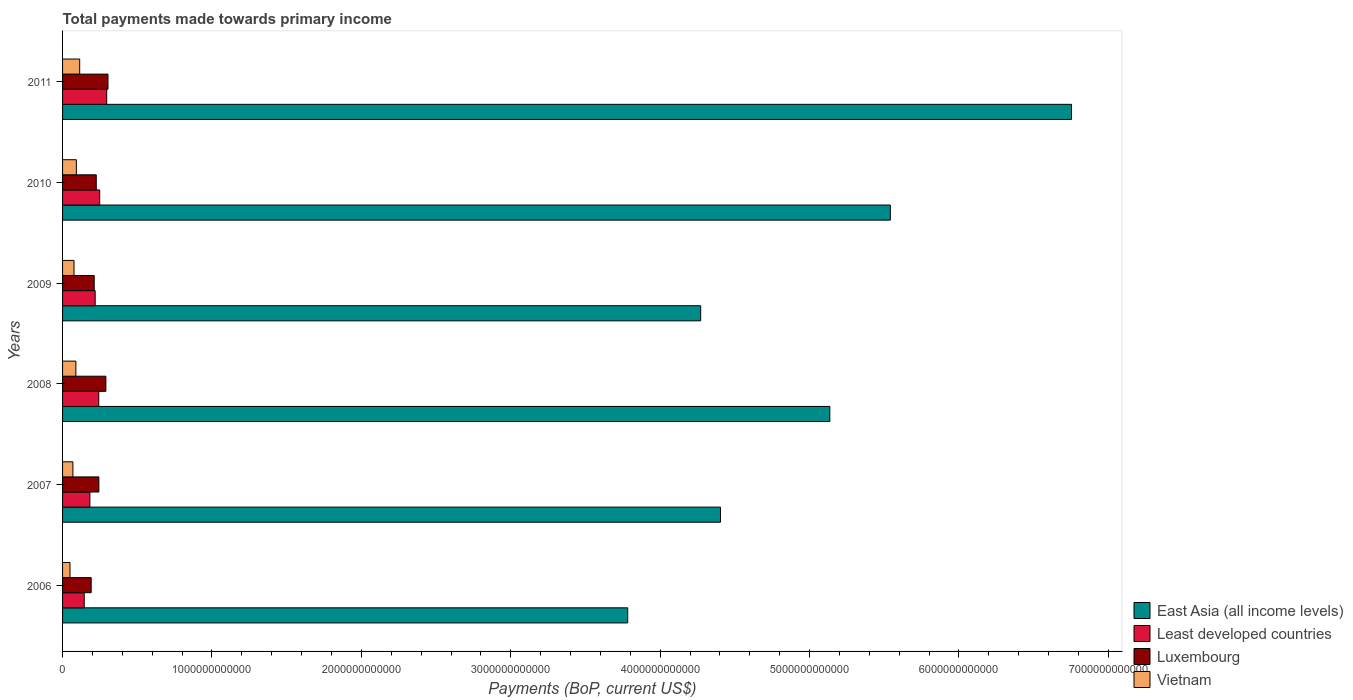How many different coloured bars are there?
Keep it short and to the point. 4. How many groups of bars are there?
Give a very brief answer. 6. Are the number of bars per tick equal to the number of legend labels?
Your response must be concise. Yes. Are the number of bars on each tick of the Y-axis equal?
Your answer should be compact. Yes. How many bars are there on the 6th tick from the top?
Your answer should be compact. 4. How many bars are there on the 4th tick from the bottom?
Offer a very short reply. 4. What is the total payments made towards primary income in Vietnam in 2010?
Give a very brief answer. 9.23e+1. Across all years, what is the maximum total payments made towards primary income in East Asia (all income levels)?
Provide a succinct answer. 6.75e+12. Across all years, what is the minimum total payments made towards primary income in Luxembourg?
Keep it short and to the point. 1.91e+11. In which year was the total payments made towards primary income in East Asia (all income levels) minimum?
Your answer should be compact. 2006. What is the total total payments made towards primary income in Least developed countries in the graph?
Your answer should be compact. 1.33e+12. What is the difference between the total payments made towards primary income in Vietnam in 2009 and that in 2011?
Offer a very short reply. -3.80e+1. What is the difference between the total payments made towards primary income in Least developed countries in 2009 and the total payments made towards primary income in Vietnam in 2011?
Provide a succinct answer. 1.04e+11. What is the average total payments made towards primary income in East Asia (all income levels) per year?
Keep it short and to the point. 4.98e+12. In the year 2011, what is the difference between the total payments made towards primary income in Vietnam and total payments made towards primary income in East Asia (all income levels)?
Your response must be concise. -6.64e+12. In how many years, is the total payments made towards primary income in East Asia (all income levels) greater than 3400000000000 US$?
Provide a succinct answer. 6. What is the ratio of the total payments made towards primary income in Vietnam in 2009 to that in 2010?
Keep it short and to the point. 0.83. Is the total payments made towards primary income in Luxembourg in 2006 less than that in 2007?
Provide a short and direct response. Yes. Is the difference between the total payments made towards primary income in Vietnam in 2009 and 2011 greater than the difference between the total payments made towards primary income in East Asia (all income levels) in 2009 and 2011?
Your answer should be compact. Yes. What is the difference between the highest and the second highest total payments made towards primary income in Luxembourg?
Provide a succinct answer. 1.41e+1. What is the difference between the highest and the lowest total payments made towards primary income in East Asia (all income levels)?
Give a very brief answer. 2.97e+12. In how many years, is the total payments made towards primary income in Luxembourg greater than the average total payments made towards primary income in Luxembourg taken over all years?
Keep it short and to the point. 2. What does the 1st bar from the top in 2009 represents?
Offer a very short reply. Vietnam. What does the 4th bar from the bottom in 2007 represents?
Your answer should be compact. Vietnam. Are all the bars in the graph horizontal?
Your answer should be very brief. Yes. What is the difference between two consecutive major ticks on the X-axis?
Your answer should be very brief. 1.00e+12. Does the graph contain any zero values?
Keep it short and to the point. No. How many legend labels are there?
Offer a very short reply. 4. How are the legend labels stacked?
Your answer should be compact. Vertical. What is the title of the graph?
Provide a succinct answer. Total payments made towards primary income. What is the label or title of the X-axis?
Give a very brief answer. Payments (BoP, current US$). What is the label or title of the Y-axis?
Provide a short and direct response. Years. What is the Payments (BoP, current US$) of East Asia (all income levels) in 2006?
Your response must be concise. 3.78e+12. What is the Payments (BoP, current US$) of Least developed countries in 2006?
Make the answer very short. 1.45e+11. What is the Payments (BoP, current US$) of Luxembourg in 2006?
Offer a very short reply. 1.91e+11. What is the Payments (BoP, current US$) of Vietnam in 2006?
Keep it short and to the point. 4.98e+1. What is the Payments (BoP, current US$) of East Asia (all income levels) in 2007?
Offer a terse response. 4.40e+12. What is the Payments (BoP, current US$) of Least developed countries in 2007?
Keep it short and to the point. 1.83e+11. What is the Payments (BoP, current US$) in Luxembourg in 2007?
Keep it short and to the point. 2.43e+11. What is the Payments (BoP, current US$) of Vietnam in 2007?
Ensure brevity in your answer.  6.91e+1. What is the Payments (BoP, current US$) of East Asia (all income levels) in 2008?
Offer a very short reply. 5.14e+12. What is the Payments (BoP, current US$) of Least developed countries in 2008?
Ensure brevity in your answer.  2.42e+11. What is the Payments (BoP, current US$) of Luxembourg in 2008?
Provide a succinct answer. 2.90e+11. What is the Payments (BoP, current US$) in Vietnam in 2008?
Your response must be concise. 8.92e+1. What is the Payments (BoP, current US$) of East Asia (all income levels) in 2009?
Ensure brevity in your answer.  4.27e+12. What is the Payments (BoP, current US$) of Least developed countries in 2009?
Provide a short and direct response. 2.18e+11. What is the Payments (BoP, current US$) of Luxembourg in 2009?
Ensure brevity in your answer.  2.12e+11. What is the Payments (BoP, current US$) of Vietnam in 2009?
Provide a succinct answer. 7.67e+1. What is the Payments (BoP, current US$) of East Asia (all income levels) in 2010?
Provide a short and direct response. 5.54e+12. What is the Payments (BoP, current US$) of Least developed countries in 2010?
Keep it short and to the point. 2.49e+11. What is the Payments (BoP, current US$) of Luxembourg in 2010?
Make the answer very short. 2.26e+11. What is the Payments (BoP, current US$) of Vietnam in 2010?
Your answer should be compact. 9.23e+1. What is the Payments (BoP, current US$) of East Asia (all income levels) in 2011?
Make the answer very short. 6.75e+12. What is the Payments (BoP, current US$) of Least developed countries in 2011?
Provide a succinct answer. 2.95e+11. What is the Payments (BoP, current US$) of Luxembourg in 2011?
Provide a succinct answer. 3.04e+11. What is the Payments (BoP, current US$) in Vietnam in 2011?
Make the answer very short. 1.15e+11. Across all years, what is the maximum Payments (BoP, current US$) of East Asia (all income levels)?
Give a very brief answer. 6.75e+12. Across all years, what is the maximum Payments (BoP, current US$) of Least developed countries?
Keep it short and to the point. 2.95e+11. Across all years, what is the maximum Payments (BoP, current US$) of Luxembourg?
Provide a succinct answer. 3.04e+11. Across all years, what is the maximum Payments (BoP, current US$) in Vietnam?
Provide a short and direct response. 1.15e+11. Across all years, what is the minimum Payments (BoP, current US$) in East Asia (all income levels)?
Offer a terse response. 3.78e+12. Across all years, what is the minimum Payments (BoP, current US$) of Least developed countries?
Give a very brief answer. 1.45e+11. Across all years, what is the minimum Payments (BoP, current US$) in Luxembourg?
Ensure brevity in your answer.  1.91e+11. Across all years, what is the minimum Payments (BoP, current US$) in Vietnam?
Ensure brevity in your answer.  4.98e+1. What is the total Payments (BoP, current US$) of East Asia (all income levels) in the graph?
Offer a very short reply. 2.99e+13. What is the total Payments (BoP, current US$) in Least developed countries in the graph?
Make the answer very short. 1.33e+12. What is the total Payments (BoP, current US$) in Luxembourg in the graph?
Your response must be concise. 1.47e+12. What is the total Payments (BoP, current US$) in Vietnam in the graph?
Your response must be concise. 4.92e+11. What is the difference between the Payments (BoP, current US$) of East Asia (all income levels) in 2006 and that in 2007?
Ensure brevity in your answer.  -6.21e+11. What is the difference between the Payments (BoP, current US$) of Least developed countries in 2006 and that in 2007?
Your answer should be very brief. -3.78e+1. What is the difference between the Payments (BoP, current US$) in Luxembourg in 2006 and that in 2007?
Provide a short and direct response. -5.16e+1. What is the difference between the Payments (BoP, current US$) in Vietnam in 2006 and that in 2007?
Give a very brief answer. -1.93e+1. What is the difference between the Payments (BoP, current US$) of East Asia (all income levels) in 2006 and that in 2008?
Keep it short and to the point. -1.35e+12. What is the difference between the Payments (BoP, current US$) in Least developed countries in 2006 and that in 2008?
Provide a short and direct response. -9.73e+1. What is the difference between the Payments (BoP, current US$) of Luxembourg in 2006 and that in 2008?
Your response must be concise. -9.85e+1. What is the difference between the Payments (BoP, current US$) in Vietnam in 2006 and that in 2008?
Provide a succinct answer. -3.94e+1. What is the difference between the Payments (BoP, current US$) in East Asia (all income levels) in 2006 and that in 2009?
Your answer should be compact. -4.89e+11. What is the difference between the Payments (BoP, current US$) of Least developed countries in 2006 and that in 2009?
Provide a short and direct response. -7.33e+1. What is the difference between the Payments (BoP, current US$) of Luxembourg in 2006 and that in 2009?
Provide a short and direct response. -2.05e+1. What is the difference between the Payments (BoP, current US$) in Vietnam in 2006 and that in 2009?
Give a very brief answer. -2.69e+1. What is the difference between the Payments (BoP, current US$) in East Asia (all income levels) in 2006 and that in 2010?
Keep it short and to the point. -1.76e+12. What is the difference between the Payments (BoP, current US$) in Least developed countries in 2006 and that in 2010?
Keep it short and to the point. -1.04e+11. What is the difference between the Payments (BoP, current US$) in Luxembourg in 2006 and that in 2010?
Ensure brevity in your answer.  -3.42e+1. What is the difference between the Payments (BoP, current US$) of Vietnam in 2006 and that in 2010?
Give a very brief answer. -4.25e+1. What is the difference between the Payments (BoP, current US$) of East Asia (all income levels) in 2006 and that in 2011?
Make the answer very short. -2.97e+12. What is the difference between the Payments (BoP, current US$) of Least developed countries in 2006 and that in 2011?
Your response must be concise. -1.50e+11. What is the difference between the Payments (BoP, current US$) in Luxembourg in 2006 and that in 2011?
Your response must be concise. -1.13e+11. What is the difference between the Payments (BoP, current US$) of Vietnam in 2006 and that in 2011?
Your answer should be very brief. -6.48e+1. What is the difference between the Payments (BoP, current US$) in East Asia (all income levels) in 2007 and that in 2008?
Offer a very short reply. -7.32e+11. What is the difference between the Payments (BoP, current US$) in Least developed countries in 2007 and that in 2008?
Your response must be concise. -5.95e+1. What is the difference between the Payments (BoP, current US$) in Luxembourg in 2007 and that in 2008?
Ensure brevity in your answer.  -4.70e+1. What is the difference between the Payments (BoP, current US$) in Vietnam in 2007 and that in 2008?
Make the answer very short. -2.00e+1. What is the difference between the Payments (BoP, current US$) of East Asia (all income levels) in 2007 and that in 2009?
Your response must be concise. 1.33e+11. What is the difference between the Payments (BoP, current US$) in Least developed countries in 2007 and that in 2009?
Your answer should be compact. -3.54e+1. What is the difference between the Payments (BoP, current US$) of Luxembourg in 2007 and that in 2009?
Your answer should be compact. 3.11e+1. What is the difference between the Payments (BoP, current US$) of Vietnam in 2007 and that in 2009?
Provide a succinct answer. -7.53e+09. What is the difference between the Payments (BoP, current US$) in East Asia (all income levels) in 2007 and that in 2010?
Your answer should be very brief. -1.14e+12. What is the difference between the Payments (BoP, current US$) of Least developed countries in 2007 and that in 2010?
Give a very brief answer. -6.57e+1. What is the difference between the Payments (BoP, current US$) in Luxembourg in 2007 and that in 2010?
Keep it short and to the point. 1.74e+1. What is the difference between the Payments (BoP, current US$) of Vietnam in 2007 and that in 2010?
Your answer should be very brief. -2.32e+1. What is the difference between the Payments (BoP, current US$) of East Asia (all income levels) in 2007 and that in 2011?
Offer a very short reply. -2.35e+12. What is the difference between the Payments (BoP, current US$) of Least developed countries in 2007 and that in 2011?
Your answer should be compact. -1.13e+11. What is the difference between the Payments (BoP, current US$) in Luxembourg in 2007 and that in 2011?
Provide a short and direct response. -6.10e+1. What is the difference between the Payments (BoP, current US$) of Vietnam in 2007 and that in 2011?
Provide a succinct answer. -4.55e+1. What is the difference between the Payments (BoP, current US$) of East Asia (all income levels) in 2008 and that in 2009?
Offer a terse response. 8.64e+11. What is the difference between the Payments (BoP, current US$) in Least developed countries in 2008 and that in 2009?
Keep it short and to the point. 2.40e+1. What is the difference between the Payments (BoP, current US$) of Luxembourg in 2008 and that in 2009?
Offer a very short reply. 7.80e+1. What is the difference between the Payments (BoP, current US$) in Vietnam in 2008 and that in 2009?
Provide a succinct answer. 1.25e+1. What is the difference between the Payments (BoP, current US$) in East Asia (all income levels) in 2008 and that in 2010?
Provide a short and direct response. -4.05e+11. What is the difference between the Payments (BoP, current US$) in Least developed countries in 2008 and that in 2010?
Ensure brevity in your answer.  -6.20e+09. What is the difference between the Payments (BoP, current US$) in Luxembourg in 2008 and that in 2010?
Keep it short and to the point. 6.43e+1. What is the difference between the Payments (BoP, current US$) of Vietnam in 2008 and that in 2010?
Provide a succinct answer. -3.13e+09. What is the difference between the Payments (BoP, current US$) of East Asia (all income levels) in 2008 and that in 2011?
Ensure brevity in your answer.  -1.62e+12. What is the difference between the Payments (BoP, current US$) of Least developed countries in 2008 and that in 2011?
Ensure brevity in your answer.  -5.31e+1. What is the difference between the Payments (BoP, current US$) of Luxembourg in 2008 and that in 2011?
Give a very brief answer. -1.41e+1. What is the difference between the Payments (BoP, current US$) in Vietnam in 2008 and that in 2011?
Offer a very short reply. -2.54e+1. What is the difference between the Payments (BoP, current US$) of East Asia (all income levels) in 2009 and that in 2010?
Give a very brief answer. -1.27e+12. What is the difference between the Payments (BoP, current US$) in Least developed countries in 2009 and that in 2010?
Make the answer very short. -3.02e+1. What is the difference between the Payments (BoP, current US$) in Luxembourg in 2009 and that in 2010?
Make the answer very short. -1.37e+1. What is the difference between the Payments (BoP, current US$) of Vietnam in 2009 and that in 2010?
Your answer should be compact. -1.56e+1. What is the difference between the Payments (BoP, current US$) of East Asia (all income levels) in 2009 and that in 2011?
Your answer should be compact. -2.48e+12. What is the difference between the Payments (BoP, current US$) in Least developed countries in 2009 and that in 2011?
Offer a terse response. -7.71e+1. What is the difference between the Payments (BoP, current US$) of Luxembourg in 2009 and that in 2011?
Provide a short and direct response. -9.21e+1. What is the difference between the Payments (BoP, current US$) in Vietnam in 2009 and that in 2011?
Offer a very short reply. -3.80e+1. What is the difference between the Payments (BoP, current US$) of East Asia (all income levels) in 2010 and that in 2011?
Provide a succinct answer. -1.21e+12. What is the difference between the Payments (BoP, current US$) of Least developed countries in 2010 and that in 2011?
Offer a very short reply. -4.69e+1. What is the difference between the Payments (BoP, current US$) in Luxembourg in 2010 and that in 2011?
Provide a succinct answer. -7.84e+1. What is the difference between the Payments (BoP, current US$) of Vietnam in 2010 and that in 2011?
Your response must be concise. -2.23e+1. What is the difference between the Payments (BoP, current US$) of East Asia (all income levels) in 2006 and the Payments (BoP, current US$) of Least developed countries in 2007?
Make the answer very short. 3.60e+12. What is the difference between the Payments (BoP, current US$) of East Asia (all income levels) in 2006 and the Payments (BoP, current US$) of Luxembourg in 2007?
Ensure brevity in your answer.  3.54e+12. What is the difference between the Payments (BoP, current US$) of East Asia (all income levels) in 2006 and the Payments (BoP, current US$) of Vietnam in 2007?
Make the answer very short. 3.71e+12. What is the difference between the Payments (BoP, current US$) of Least developed countries in 2006 and the Payments (BoP, current US$) of Luxembourg in 2007?
Ensure brevity in your answer.  -9.80e+1. What is the difference between the Payments (BoP, current US$) of Least developed countries in 2006 and the Payments (BoP, current US$) of Vietnam in 2007?
Your response must be concise. 7.59e+1. What is the difference between the Payments (BoP, current US$) in Luxembourg in 2006 and the Payments (BoP, current US$) in Vietnam in 2007?
Give a very brief answer. 1.22e+11. What is the difference between the Payments (BoP, current US$) in East Asia (all income levels) in 2006 and the Payments (BoP, current US$) in Least developed countries in 2008?
Ensure brevity in your answer.  3.54e+12. What is the difference between the Payments (BoP, current US$) of East Asia (all income levels) in 2006 and the Payments (BoP, current US$) of Luxembourg in 2008?
Keep it short and to the point. 3.49e+12. What is the difference between the Payments (BoP, current US$) of East Asia (all income levels) in 2006 and the Payments (BoP, current US$) of Vietnam in 2008?
Your response must be concise. 3.69e+12. What is the difference between the Payments (BoP, current US$) in Least developed countries in 2006 and the Payments (BoP, current US$) in Luxembourg in 2008?
Provide a short and direct response. -1.45e+11. What is the difference between the Payments (BoP, current US$) in Least developed countries in 2006 and the Payments (BoP, current US$) in Vietnam in 2008?
Your response must be concise. 5.59e+1. What is the difference between the Payments (BoP, current US$) in Luxembourg in 2006 and the Payments (BoP, current US$) in Vietnam in 2008?
Keep it short and to the point. 1.02e+11. What is the difference between the Payments (BoP, current US$) of East Asia (all income levels) in 2006 and the Payments (BoP, current US$) of Least developed countries in 2009?
Provide a succinct answer. 3.56e+12. What is the difference between the Payments (BoP, current US$) in East Asia (all income levels) in 2006 and the Payments (BoP, current US$) in Luxembourg in 2009?
Your response must be concise. 3.57e+12. What is the difference between the Payments (BoP, current US$) in East Asia (all income levels) in 2006 and the Payments (BoP, current US$) in Vietnam in 2009?
Offer a terse response. 3.71e+12. What is the difference between the Payments (BoP, current US$) in Least developed countries in 2006 and the Payments (BoP, current US$) in Luxembourg in 2009?
Your response must be concise. -6.69e+1. What is the difference between the Payments (BoP, current US$) in Least developed countries in 2006 and the Payments (BoP, current US$) in Vietnam in 2009?
Your answer should be very brief. 6.84e+1. What is the difference between the Payments (BoP, current US$) in Luxembourg in 2006 and the Payments (BoP, current US$) in Vietnam in 2009?
Offer a terse response. 1.15e+11. What is the difference between the Payments (BoP, current US$) of East Asia (all income levels) in 2006 and the Payments (BoP, current US$) of Least developed countries in 2010?
Provide a short and direct response. 3.53e+12. What is the difference between the Payments (BoP, current US$) of East Asia (all income levels) in 2006 and the Payments (BoP, current US$) of Luxembourg in 2010?
Your answer should be very brief. 3.56e+12. What is the difference between the Payments (BoP, current US$) of East Asia (all income levels) in 2006 and the Payments (BoP, current US$) of Vietnam in 2010?
Your response must be concise. 3.69e+12. What is the difference between the Payments (BoP, current US$) in Least developed countries in 2006 and the Payments (BoP, current US$) in Luxembourg in 2010?
Your answer should be compact. -8.06e+1. What is the difference between the Payments (BoP, current US$) of Least developed countries in 2006 and the Payments (BoP, current US$) of Vietnam in 2010?
Make the answer very short. 5.27e+1. What is the difference between the Payments (BoP, current US$) in Luxembourg in 2006 and the Payments (BoP, current US$) in Vietnam in 2010?
Your answer should be compact. 9.91e+1. What is the difference between the Payments (BoP, current US$) in East Asia (all income levels) in 2006 and the Payments (BoP, current US$) in Least developed countries in 2011?
Your response must be concise. 3.49e+12. What is the difference between the Payments (BoP, current US$) of East Asia (all income levels) in 2006 and the Payments (BoP, current US$) of Luxembourg in 2011?
Make the answer very short. 3.48e+12. What is the difference between the Payments (BoP, current US$) of East Asia (all income levels) in 2006 and the Payments (BoP, current US$) of Vietnam in 2011?
Ensure brevity in your answer.  3.67e+12. What is the difference between the Payments (BoP, current US$) in Least developed countries in 2006 and the Payments (BoP, current US$) in Luxembourg in 2011?
Your answer should be very brief. -1.59e+11. What is the difference between the Payments (BoP, current US$) of Least developed countries in 2006 and the Payments (BoP, current US$) of Vietnam in 2011?
Your answer should be very brief. 3.04e+1. What is the difference between the Payments (BoP, current US$) of Luxembourg in 2006 and the Payments (BoP, current US$) of Vietnam in 2011?
Provide a succinct answer. 7.68e+1. What is the difference between the Payments (BoP, current US$) of East Asia (all income levels) in 2007 and the Payments (BoP, current US$) of Least developed countries in 2008?
Provide a succinct answer. 4.16e+12. What is the difference between the Payments (BoP, current US$) in East Asia (all income levels) in 2007 and the Payments (BoP, current US$) in Luxembourg in 2008?
Make the answer very short. 4.11e+12. What is the difference between the Payments (BoP, current US$) in East Asia (all income levels) in 2007 and the Payments (BoP, current US$) in Vietnam in 2008?
Make the answer very short. 4.31e+12. What is the difference between the Payments (BoP, current US$) in Least developed countries in 2007 and the Payments (BoP, current US$) in Luxembourg in 2008?
Your response must be concise. -1.07e+11. What is the difference between the Payments (BoP, current US$) in Least developed countries in 2007 and the Payments (BoP, current US$) in Vietnam in 2008?
Give a very brief answer. 9.37e+1. What is the difference between the Payments (BoP, current US$) in Luxembourg in 2007 and the Payments (BoP, current US$) in Vietnam in 2008?
Provide a succinct answer. 1.54e+11. What is the difference between the Payments (BoP, current US$) in East Asia (all income levels) in 2007 and the Payments (BoP, current US$) in Least developed countries in 2009?
Give a very brief answer. 4.19e+12. What is the difference between the Payments (BoP, current US$) of East Asia (all income levels) in 2007 and the Payments (BoP, current US$) of Luxembourg in 2009?
Give a very brief answer. 4.19e+12. What is the difference between the Payments (BoP, current US$) in East Asia (all income levels) in 2007 and the Payments (BoP, current US$) in Vietnam in 2009?
Your response must be concise. 4.33e+12. What is the difference between the Payments (BoP, current US$) in Least developed countries in 2007 and the Payments (BoP, current US$) in Luxembourg in 2009?
Ensure brevity in your answer.  -2.90e+1. What is the difference between the Payments (BoP, current US$) in Least developed countries in 2007 and the Payments (BoP, current US$) in Vietnam in 2009?
Offer a very short reply. 1.06e+11. What is the difference between the Payments (BoP, current US$) in Luxembourg in 2007 and the Payments (BoP, current US$) in Vietnam in 2009?
Your response must be concise. 1.66e+11. What is the difference between the Payments (BoP, current US$) in East Asia (all income levels) in 2007 and the Payments (BoP, current US$) in Least developed countries in 2010?
Offer a terse response. 4.16e+12. What is the difference between the Payments (BoP, current US$) of East Asia (all income levels) in 2007 and the Payments (BoP, current US$) of Luxembourg in 2010?
Your answer should be very brief. 4.18e+12. What is the difference between the Payments (BoP, current US$) in East Asia (all income levels) in 2007 and the Payments (BoP, current US$) in Vietnam in 2010?
Provide a succinct answer. 4.31e+12. What is the difference between the Payments (BoP, current US$) of Least developed countries in 2007 and the Payments (BoP, current US$) of Luxembourg in 2010?
Make the answer very short. -4.27e+1. What is the difference between the Payments (BoP, current US$) of Least developed countries in 2007 and the Payments (BoP, current US$) of Vietnam in 2010?
Make the answer very short. 9.06e+1. What is the difference between the Payments (BoP, current US$) of Luxembourg in 2007 and the Payments (BoP, current US$) of Vietnam in 2010?
Your answer should be very brief. 1.51e+11. What is the difference between the Payments (BoP, current US$) of East Asia (all income levels) in 2007 and the Payments (BoP, current US$) of Least developed countries in 2011?
Provide a succinct answer. 4.11e+12. What is the difference between the Payments (BoP, current US$) in East Asia (all income levels) in 2007 and the Payments (BoP, current US$) in Luxembourg in 2011?
Offer a terse response. 4.10e+12. What is the difference between the Payments (BoP, current US$) in East Asia (all income levels) in 2007 and the Payments (BoP, current US$) in Vietnam in 2011?
Give a very brief answer. 4.29e+12. What is the difference between the Payments (BoP, current US$) of Least developed countries in 2007 and the Payments (BoP, current US$) of Luxembourg in 2011?
Offer a terse response. -1.21e+11. What is the difference between the Payments (BoP, current US$) in Least developed countries in 2007 and the Payments (BoP, current US$) in Vietnam in 2011?
Your response must be concise. 6.82e+1. What is the difference between the Payments (BoP, current US$) in Luxembourg in 2007 and the Payments (BoP, current US$) in Vietnam in 2011?
Make the answer very short. 1.28e+11. What is the difference between the Payments (BoP, current US$) of East Asia (all income levels) in 2008 and the Payments (BoP, current US$) of Least developed countries in 2009?
Your answer should be very brief. 4.92e+12. What is the difference between the Payments (BoP, current US$) in East Asia (all income levels) in 2008 and the Payments (BoP, current US$) in Luxembourg in 2009?
Ensure brevity in your answer.  4.92e+12. What is the difference between the Payments (BoP, current US$) of East Asia (all income levels) in 2008 and the Payments (BoP, current US$) of Vietnam in 2009?
Keep it short and to the point. 5.06e+12. What is the difference between the Payments (BoP, current US$) of Least developed countries in 2008 and the Payments (BoP, current US$) of Luxembourg in 2009?
Give a very brief answer. 3.04e+1. What is the difference between the Payments (BoP, current US$) of Least developed countries in 2008 and the Payments (BoP, current US$) of Vietnam in 2009?
Make the answer very short. 1.66e+11. What is the difference between the Payments (BoP, current US$) in Luxembourg in 2008 and the Payments (BoP, current US$) in Vietnam in 2009?
Offer a terse response. 2.13e+11. What is the difference between the Payments (BoP, current US$) of East Asia (all income levels) in 2008 and the Payments (BoP, current US$) of Least developed countries in 2010?
Make the answer very short. 4.89e+12. What is the difference between the Payments (BoP, current US$) in East Asia (all income levels) in 2008 and the Payments (BoP, current US$) in Luxembourg in 2010?
Give a very brief answer. 4.91e+12. What is the difference between the Payments (BoP, current US$) in East Asia (all income levels) in 2008 and the Payments (BoP, current US$) in Vietnam in 2010?
Your response must be concise. 5.04e+12. What is the difference between the Payments (BoP, current US$) in Least developed countries in 2008 and the Payments (BoP, current US$) in Luxembourg in 2010?
Your answer should be compact. 1.67e+1. What is the difference between the Payments (BoP, current US$) of Least developed countries in 2008 and the Payments (BoP, current US$) of Vietnam in 2010?
Keep it short and to the point. 1.50e+11. What is the difference between the Payments (BoP, current US$) of Luxembourg in 2008 and the Payments (BoP, current US$) of Vietnam in 2010?
Provide a succinct answer. 1.98e+11. What is the difference between the Payments (BoP, current US$) in East Asia (all income levels) in 2008 and the Payments (BoP, current US$) in Least developed countries in 2011?
Keep it short and to the point. 4.84e+12. What is the difference between the Payments (BoP, current US$) in East Asia (all income levels) in 2008 and the Payments (BoP, current US$) in Luxembourg in 2011?
Your answer should be very brief. 4.83e+12. What is the difference between the Payments (BoP, current US$) in East Asia (all income levels) in 2008 and the Payments (BoP, current US$) in Vietnam in 2011?
Provide a succinct answer. 5.02e+12. What is the difference between the Payments (BoP, current US$) of Least developed countries in 2008 and the Payments (BoP, current US$) of Luxembourg in 2011?
Provide a short and direct response. -6.17e+1. What is the difference between the Payments (BoP, current US$) in Least developed countries in 2008 and the Payments (BoP, current US$) in Vietnam in 2011?
Provide a short and direct response. 1.28e+11. What is the difference between the Payments (BoP, current US$) of Luxembourg in 2008 and the Payments (BoP, current US$) of Vietnam in 2011?
Ensure brevity in your answer.  1.75e+11. What is the difference between the Payments (BoP, current US$) in East Asia (all income levels) in 2009 and the Payments (BoP, current US$) in Least developed countries in 2010?
Keep it short and to the point. 4.02e+12. What is the difference between the Payments (BoP, current US$) of East Asia (all income levels) in 2009 and the Payments (BoP, current US$) of Luxembourg in 2010?
Your answer should be compact. 4.05e+12. What is the difference between the Payments (BoP, current US$) in East Asia (all income levels) in 2009 and the Payments (BoP, current US$) in Vietnam in 2010?
Keep it short and to the point. 4.18e+12. What is the difference between the Payments (BoP, current US$) of Least developed countries in 2009 and the Payments (BoP, current US$) of Luxembourg in 2010?
Your answer should be compact. -7.30e+09. What is the difference between the Payments (BoP, current US$) of Least developed countries in 2009 and the Payments (BoP, current US$) of Vietnam in 2010?
Your answer should be very brief. 1.26e+11. What is the difference between the Payments (BoP, current US$) in Luxembourg in 2009 and the Payments (BoP, current US$) in Vietnam in 2010?
Give a very brief answer. 1.20e+11. What is the difference between the Payments (BoP, current US$) in East Asia (all income levels) in 2009 and the Payments (BoP, current US$) in Least developed countries in 2011?
Give a very brief answer. 3.98e+12. What is the difference between the Payments (BoP, current US$) of East Asia (all income levels) in 2009 and the Payments (BoP, current US$) of Luxembourg in 2011?
Offer a terse response. 3.97e+12. What is the difference between the Payments (BoP, current US$) of East Asia (all income levels) in 2009 and the Payments (BoP, current US$) of Vietnam in 2011?
Your response must be concise. 4.16e+12. What is the difference between the Payments (BoP, current US$) in Least developed countries in 2009 and the Payments (BoP, current US$) in Luxembourg in 2011?
Ensure brevity in your answer.  -8.57e+1. What is the difference between the Payments (BoP, current US$) in Least developed countries in 2009 and the Payments (BoP, current US$) in Vietnam in 2011?
Your answer should be very brief. 1.04e+11. What is the difference between the Payments (BoP, current US$) of Luxembourg in 2009 and the Payments (BoP, current US$) of Vietnam in 2011?
Your answer should be very brief. 9.73e+1. What is the difference between the Payments (BoP, current US$) in East Asia (all income levels) in 2010 and the Payments (BoP, current US$) in Least developed countries in 2011?
Ensure brevity in your answer.  5.25e+12. What is the difference between the Payments (BoP, current US$) in East Asia (all income levels) in 2010 and the Payments (BoP, current US$) in Luxembourg in 2011?
Provide a succinct answer. 5.24e+12. What is the difference between the Payments (BoP, current US$) in East Asia (all income levels) in 2010 and the Payments (BoP, current US$) in Vietnam in 2011?
Offer a terse response. 5.43e+12. What is the difference between the Payments (BoP, current US$) in Least developed countries in 2010 and the Payments (BoP, current US$) in Luxembourg in 2011?
Provide a succinct answer. -5.55e+1. What is the difference between the Payments (BoP, current US$) in Least developed countries in 2010 and the Payments (BoP, current US$) in Vietnam in 2011?
Ensure brevity in your answer.  1.34e+11. What is the difference between the Payments (BoP, current US$) in Luxembourg in 2010 and the Payments (BoP, current US$) in Vietnam in 2011?
Make the answer very short. 1.11e+11. What is the average Payments (BoP, current US$) in East Asia (all income levels) per year?
Offer a very short reply. 4.98e+12. What is the average Payments (BoP, current US$) of Least developed countries per year?
Make the answer very short. 2.22e+11. What is the average Payments (BoP, current US$) of Luxembourg per year?
Make the answer very short. 2.44e+11. What is the average Payments (BoP, current US$) in Vietnam per year?
Provide a succinct answer. 8.20e+1. In the year 2006, what is the difference between the Payments (BoP, current US$) of East Asia (all income levels) and Payments (BoP, current US$) of Least developed countries?
Provide a short and direct response. 3.64e+12. In the year 2006, what is the difference between the Payments (BoP, current US$) in East Asia (all income levels) and Payments (BoP, current US$) in Luxembourg?
Provide a succinct answer. 3.59e+12. In the year 2006, what is the difference between the Payments (BoP, current US$) in East Asia (all income levels) and Payments (BoP, current US$) in Vietnam?
Your response must be concise. 3.73e+12. In the year 2006, what is the difference between the Payments (BoP, current US$) of Least developed countries and Payments (BoP, current US$) of Luxembourg?
Your response must be concise. -4.64e+1. In the year 2006, what is the difference between the Payments (BoP, current US$) in Least developed countries and Payments (BoP, current US$) in Vietnam?
Provide a succinct answer. 9.52e+1. In the year 2006, what is the difference between the Payments (BoP, current US$) of Luxembourg and Payments (BoP, current US$) of Vietnam?
Your response must be concise. 1.42e+11. In the year 2007, what is the difference between the Payments (BoP, current US$) of East Asia (all income levels) and Payments (BoP, current US$) of Least developed countries?
Give a very brief answer. 4.22e+12. In the year 2007, what is the difference between the Payments (BoP, current US$) in East Asia (all income levels) and Payments (BoP, current US$) in Luxembourg?
Your answer should be compact. 4.16e+12. In the year 2007, what is the difference between the Payments (BoP, current US$) of East Asia (all income levels) and Payments (BoP, current US$) of Vietnam?
Offer a very short reply. 4.33e+12. In the year 2007, what is the difference between the Payments (BoP, current US$) in Least developed countries and Payments (BoP, current US$) in Luxembourg?
Offer a terse response. -6.01e+1. In the year 2007, what is the difference between the Payments (BoP, current US$) of Least developed countries and Payments (BoP, current US$) of Vietnam?
Make the answer very short. 1.14e+11. In the year 2007, what is the difference between the Payments (BoP, current US$) of Luxembourg and Payments (BoP, current US$) of Vietnam?
Keep it short and to the point. 1.74e+11. In the year 2008, what is the difference between the Payments (BoP, current US$) of East Asia (all income levels) and Payments (BoP, current US$) of Least developed countries?
Provide a succinct answer. 4.89e+12. In the year 2008, what is the difference between the Payments (BoP, current US$) in East Asia (all income levels) and Payments (BoP, current US$) in Luxembourg?
Your answer should be very brief. 4.85e+12. In the year 2008, what is the difference between the Payments (BoP, current US$) of East Asia (all income levels) and Payments (BoP, current US$) of Vietnam?
Offer a very short reply. 5.05e+12. In the year 2008, what is the difference between the Payments (BoP, current US$) of Least developed countries and Payments (BoP, current US$) of Luxembourg?
Your answer should be compact. -4.76e+1. In the year 2008, what is the difference between the Payments (BoP, current US$) of Least developed countries and Payments (BoP, current US$) of Vietnam?
Give a very brief answer. 1.53e+11. In the year 2008, what is the difference between the Payments (BoP, current US$) in Luxembourg and Payments (BoP, current US$) in Vietnam?
Make the answer very short. 2.01e+11. In the year 2009, what is the difference between the Payments (BoP, current US$) of East Asia (all income levels) and Payments (BoP, current US$) of Least developed countries?
Provide a succinct answer. 4.05e+12. In the year 2009, what is the difference between the Payments (BoP, current US$) in East Asia (all income levels) and Payments (BoP, current US$) in Luxembourg?
Provide a succinct answer. 4.06e+12. In the year 2009, what is the difference between the Payments (BoP, current US$) of East Asia (all income levels) and Payments (BoP, current US$) of Vietnam?
Keep it short and to the point. 4.19e+12. In the year 2009, what is the difference between the Payments (BoP, current US$) of Least developed countries and Payments (BoP, current US$) of Luxembourg?
Offer a very short reply. 6.40e+09. In the year 2009, what is the difference between the Payments (BoP, current US$) in Least developed countries and Payments (BoP, current US$) in Vietnam?
Offer a very short reply. 1.42e+11. In the year 2009, what is the difference between the Payments (BoP, current US$) in Luxembourg and Payments (BoP, current US$) in Vietnam?
Provide a short and direct response. 1.35e+11. In the year 2010, what is the difference between the Payments (BoP, current US$) in East Asia (all income levels) and Payments (BoP, current US$) in Least developed countries?
Your answer should be compact. 5.29e+12. In the year 2010, what is the difference between the Payments (BoP, current US$) in East Asia (all income levels) and Payments (BoP, current US$) in Luxembourg?
Your response must be concise. 5.32e+12. In the year 2010, what is the difference between the Payments (BoP, current US$) in East Asia (all income levels) and Payments (BoP, current US$) in Vietnam?
Provide a short and direct response. 5.45e+12. In the year 2010, what is the difference between the Payments (BoP, current US$) of Least developed countries and Payments (BoP, current US$) of Luxembourg?
Keep it short and to the point. 2.29e+1. In the year 2010, what is the difference between the Payments (BoP, current US$) of Least developed countries and Payments (BoP, current US$) of Vietnam?
Give a very brief answer. 1.56e+11. In the year 2010, what is the difference between the Payments (BoP, current US$) in Luxembourg and Payments (BoP, current US$) in Vietnam?
Offer a very short reply. 1.33e+11. In the year 2011, what is the difference between the Payments (BoP, current US$) of East Asia (all income levels) and Payments (BoP, current US$) of Least developed countries?
Provide a succinct answer. 6.46e+12. In the year 2011, what is the difference between the Payments (BoP, current US$) in East Asia (all income levels) and Payments (BoP, current US$) in Luxembourg?
Provide a short and direct response. 6.45e+12. In the year 2011, what is the difference between the Payments (BoP, current US$) of East Asia (all income levels) and Payments (BoP, current US$) of Vietnam?
Give a very brief answer. 6.64e+12. In the year 2011, what is the difference between the Payments (BoP, current US$) of Least developed countries and Payments (BoP, current US$) of Luxembourg?
Keep it short and to the point. -8.59e+09. In the year 2011, what is the difference between the Payments (BoP, current US$) of Least developed countries and Payments (BoP, current US$) of Vietnam?
Offer a very short reply. 1.81e+11. In the year 2011, what is the difference between the Payments (BoP, current US$) of Luxembourg and Payments (BoP, current US$) of Vietnam?
Provide a succinct answer. 1.89e+11. What is the ratio of the Payments (BoP, current US$) in East Asia (all income levels) in 2006 to that in 2007?
Your answer should be very brief. 0.86. What is the ratio of the Payments (BoP, current US$) in Least developed countries in 2006 to that in 2007?
Give a very brief answer. 0.79. What is the ratio of the Payments (BoP, current US$) of Luxembourg in 2006 to that in 2007?
Your answer should be compact. 0.79. What is the ratio of the Payments (BoP, current US$) in Vietnam in 2006 to that in 2007?
Offer a very short reply. 0.72. What is the ratio of the Payments (BoP, current US$) of East Asia (all income levels) in 2006 to that in 2008?
Provide a succinct answer. 0.74. What is the ratio of the Payments (BoP, current US$) of Least developed countries in 2006 to that in 2008?
Make the answer very short. 0.6. What is the ratio of the Payments (BoP, current US$) in Luxembourg in 2006 to that in 2008?
Provide a short and direct response. 0.66. What is the ratio of the Payments (BoP, current US$) of Vietnam in 2006 to that in 2008?
Your answer should be compact. 0.56. What is the ratio of the Payments (BoP, current US$) in East Asia (all income levels) in 2006 to that in 2009?
Keep it short and to the point. 0.89. What is the ratio of the Payments (BoP, current US$) of Least developed countries in 2006 to that in 2009?
Your answer should be very brief. 0.66. What is the ratio of the Payments (BoP, current US$) of Luxembourg in 2006 to that in 2009?
Give a very brief answer. 0.9. What is the ratio of the Payments (BoP, current US$) of Vietnam in 2006 to that in 2009?
Provide a short and direct response. 0.65. What is the ratio of the Payments (BoP, current US$) of East Asia (all income levels) in 2006 to that in 2010?
Ensure brevity in your answer.  0.68. What is the ratio of the Payments (BoP, current US$) in Least developed countries in 2006 to that in 2010?
Keep it short and to the point. 0.58. What is the ratio of the Payments (BoP, current US$) in Luxembourg in 2006 to that in 2010?
Make the answer very short. 0.85. What is the ratio of the Payments (BoP, current US$) of Vietnam in 2006 to that in 2010?
Make the answer very short. 0.54. What is the ratio of the Payments (BoP, current US$) in East Asia (all income levels) in 2006 to that in 2011?
Give a very brief answer. 0.56. What is the ratio of the Payments (BoP, current US$) in Least developed countries in 2006 to that in 2011?
Ensure brevity in your answer.  0.49. What is the ratio of the Payments (BoP, current US$) of Luxembourg in 2006 to that in 2011?
Your response must be concise. 0.63. What is the ratio of the Payments (BoP, current US$) of Vietnam in 2006 to that in 2011?
Your answer should be compact. 0.43. What is the ratio of the Payments (BoP, current US$) of East Asia (all income levels) in 2007 to that in 2008?
Offer a terse response. 0.86. What is the ratio of the Payments (BoP, current US$) of Least developed countries in 2007 to that in 2008?
Offer a very short reply. 0.75. What is the ratio of the Payments (BoP, current US$) in Luxembourg in 2007 to that in 2008?
Your answer should be very brief. 0.84. What is the ratio of the Payments (BoP, current US$) of Vietnam in 2007 to that in 2008?
Keep it short and to the point. 0.78. What is the ratio of the Payments (BoP, current US$) of East Asia (all income levels) in 2007 to that in 2009?
Provide a short and direct response. 1.03. What is the ratio of the Payments (BoP, current US$) of Least developed countries in 2007 to that in 2009?
Offer a very short reply. 0.84. What is the ratio of the Payments (BoP, current US$) of Luxembourg in 2007 to that in 2009?
Your answer should be compact. 1.15. What is the ratio of the Payments (BoP, current US$) in Vietnam in 2007 to that in 2009?
Your answer should be very brief. 0.9. What is the ratio of the Payments (BoP, current US$) of East Asia (all income levels) in 2007 to that in 2010?
Offer a very short reply. 0.79. What is the ratio of the Payments (BoP, current US$) of Least developed countries in 2007 to that in 2010?
Your answer should be compact. 0.74. What is the ratio of the Payments (BoP, current US$) in Luxembourg in 2007 to that in 2010?
Your response must be concise. 1.08. What is the ratio of the Payments (BoP, current US$) in Vietnam in 2007 to that in 2010?
Give a very brief answer. 0.75. What is the ratio of the Payments (BoP, current US$) of East Asia (all income levels) in 2007 to that in 2011?
Give a very brief answer. 0.65. What is the ratio of the Payments (BoP, current US$) of Least developed countries in 2007 to that in 2011?
Offer a terse response. 0.62. What is the ratio of the Payments (BoP, current US$) in Luxembourg in 2007 to that in 2011?
Ensure brevity in your answer.  0.8. What is the ratio of the Payments (BoP, current US$) in Vietnam in 2007 to that in 2011?
Offer a terse response. 0.6. What is the ratio of the Payments (BoP, current US$) of East Asia (all income levels) in 2008 to that in 2009?
Provide a succinct answer. 1.2. What is the ratio of the Payments (BoP, current US$) of Least developed countries in 2008 to that in 2009?
Your response must be concise. 1.11. What is the ratio of the Payments (BoP, current US$) in Luxembourg in 2008 to that in 2009?
Ensure brevity in your answer.  1.37. What is the ratio of the Payments (BoP, current US$) in Vietnam in 2008 to that in 2009?
Your answer should be very brief. 1.16. What is the ratio of the Payments (BoP, current US$) of East Asia (all income levels) in 2008 to that in 2010?
Make the answer very short. 0.93. What is the ratio of the Payments (BoP, current US$) in Luxembourg in 2008 to that in 2010?
Your answer should be compact. 1.29. What is the ratio of the Payments (BoP, current US$) in Vietnam in 2008 to that in 2010?
Give a very brief answer. 0.97. What is the ratio of the Payments (BoP, current US$) in East Asia (all income levels) in 2008 to that in 2011?
Offer a terse response. 0.76. What is the ratio of the Payments (BoP, current US$) in Least developed countries in 2008 to that in 2011?
Provide a short and direct response. 0.82. What is the ratio of the Payments (BoP, current US$) of Luxembourg in 2008 to that in 2011?
Provide a short and direct response. 0.95. What is the ratio of the Payments (BoP, current US$) in Vietnam in 2008 to that in 2011?
Make the answer very short. 0.78. What is the ratio of the Payments (BoP, current US$) of East Asia (all income levels) in 2009 to that in 2010?
Your answer should be very brief. 0.77. What is the ratio of the Payments (BoP, current US$) of Least developed countries in 2009 to that in 2010?
Your answer should be very brief. 0.88. What is the ratio of the Payments (BoP, current US$) of Luxembourg in 2009 to that in 2010?
Ensure brevity in your answer.  0.94. What is the ratio of the Payments (BoP, current US$) in Vietnam in 2009 to that in 2010?
Offer a terse response. 0.83. What is the ratio of the Payments (BoP, current US$) of East Asia (all income levels) in 2009 to that in 2011?
Give a very brief answer. 0.63. What is the ratio of the Payments (BoP, current US$) of Least developed countries in 2009 to that in 2011?
Provide a short and direct response. 0.74. What is the ratio of the Payments (BoP, current US$) in Luxembourg in 2009 to that in 2011?
Your response must be concise. 0.7. What is the ratio of the Payments (BoP, current US$) of Vietnam in 2009 to that in 2011?
Offer a very short reply. 0.67. What is the ratio of the Payments (BoP, current US$) in East Asia (all income levels) in 2010 to that in 2011?
Give a very brief answer. 0.82. What is the ratio of the Payments (BoP, current US$) in Least developed countries in 2010 to that in 2011?
Keep it short and to the point. 0.84. What is the ratio of the Payments (BoP, current US$) of Luxembourg in 2010 to that in 2011?
Provide a short and direct response. 0.74. What is the ratio of the Payments (BoP, current US$) of Vietnam in 2010 to that in 2011?
Offer a very short reply. 0.81. What is the difference between the highest and the second highest Payments (BoP, current US$) in East Asia (all income levels)?
Make the answer very short. 1.21e+12. What is the difference between the highest and the second highest Payments (BoP, current US$) of Least developed countries?
Make the answer very short. 4.69e+1. What is the difference between the highest and the second highest Payments (BoP, current US$) of Luxembourg?
Offer a very short reply. 1.41e+1. What is the difference between the highest and the second highest Payments (BoP, current US$) of Vietnam?
Offer a terse response. 2.23e+1. What is the difference between the highest and the lowest Payments (BoP, current US$) in East Asia (all income levels)?
Provide a succinct answer. 2.97e+12. What is the difference between the highest and the lowest Payments (BoP, current US$) of Least developed countries?
Provide a succinct answer. 1.50e+11. What is the difference between the highest and the lowest Payments (BoP, current US$) of Luxembourg?
Keep it short and to the point. 1.13e+11. What is the difference between the highest and the lowest Payments (BoP, current US$) in Vietnam?
Your answer should be compact. 6.48e+1. 